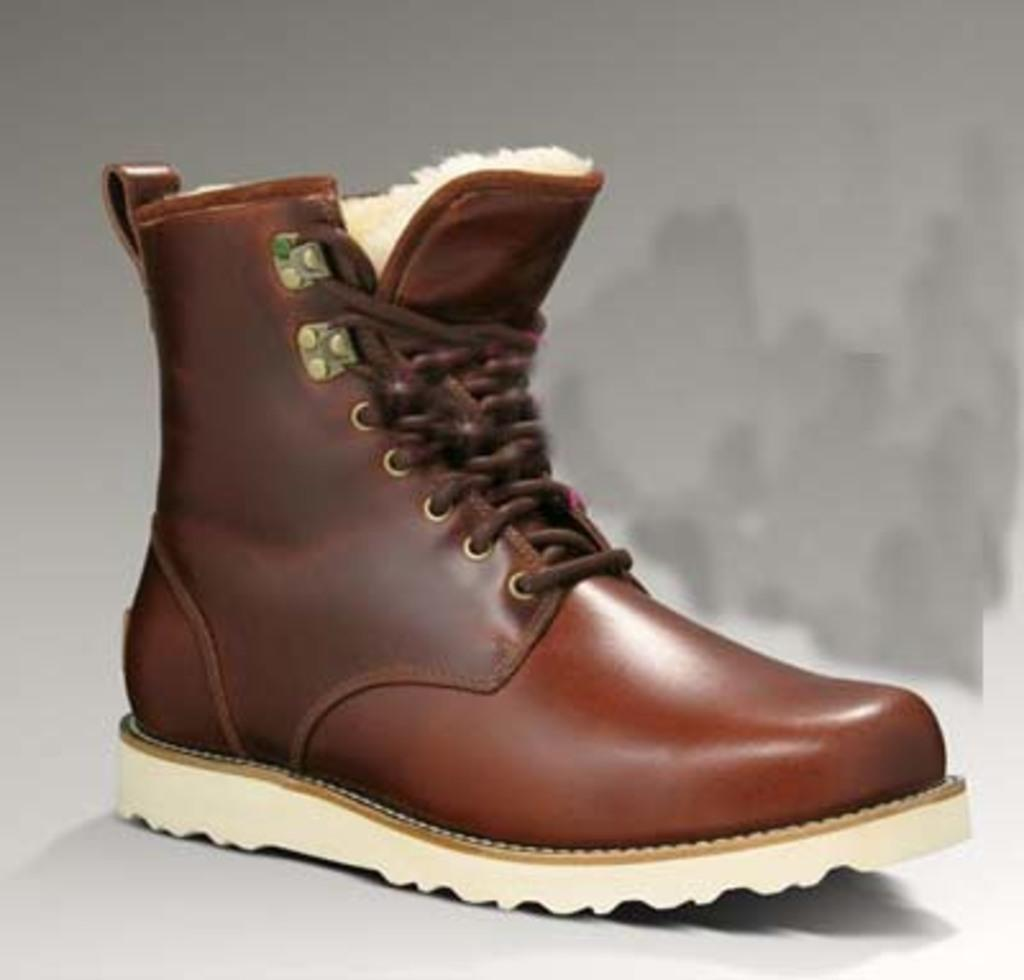What object is the main subject of the image? There is a shoe in the image. What color is the background of the image? The background of the image is white. Can you tell me how many women are present in the image? There is no woman present in the image; it features a shoe on a white background. What type of finger can be seen interacting with the shoe in the image? There is no finger present in the image; it only features a shoe on a white background. 